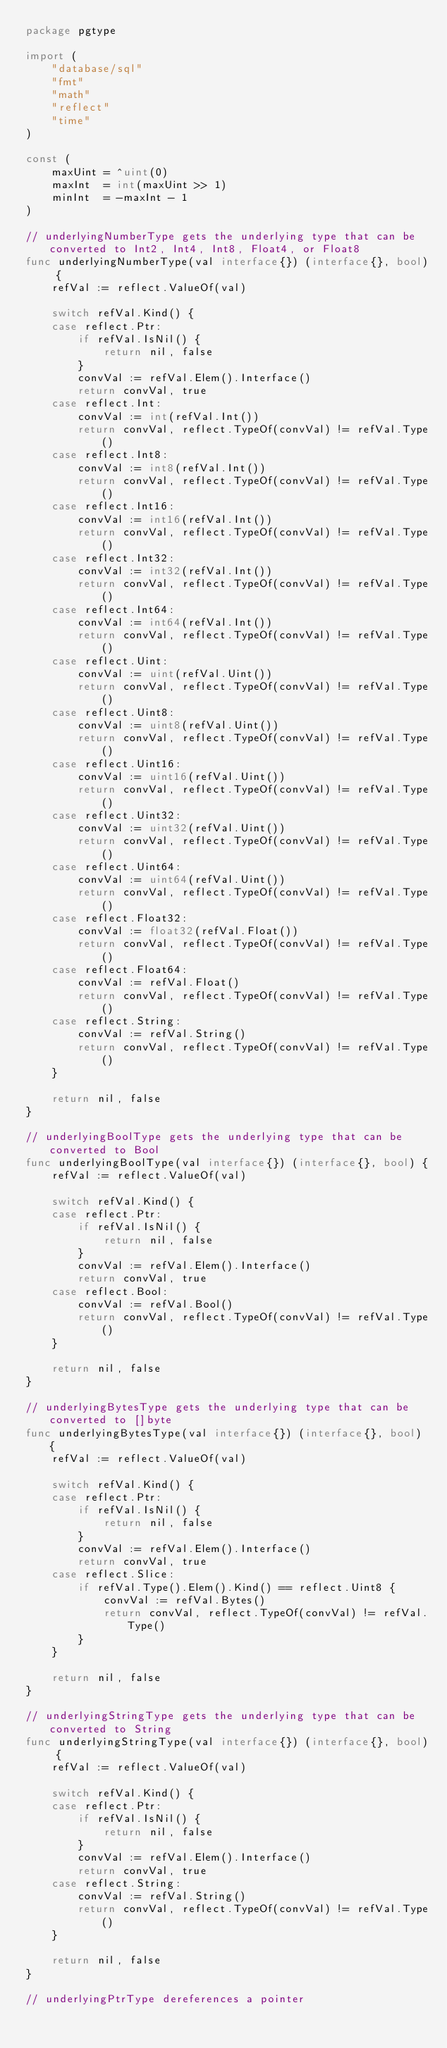Convert code to text. <code><loc_0><loc_0><loc_500><loc_500><_Go_>package pgtype

import (
	"database/sql"
	"fmt"
	"math"
	"reflect"
	"time"
)

const (
	maxUint = ^uint(0)
	maxInt  = int(maxUint >> 1)
	minInt  = -maxInt - 1
)

// underlyingNumberType gets the underlying type that can be converted to Int2, Int4, Int8, Float4, or Float8
func underlyingNumberType(val interface{}) (interface{}, bool) {
	refVal := reflect.ValueOf(val)

	switch refVal.Kind() {
	case reflect.Ptr:
		if refVal.IsNil() {
			return nil, false
		}
		convVal := refVal.Elem().Interface()
		return convVal, true
	case reflect.Int:
		convVal := int(refVal.Int())
		return convVal, reflect.TypeOf(convVal) != refVal.Type()
	case reflect.Int8:
		convVal := int8(refVal.Int())
		return convVal, reflect.TypeOf(convVal) != refVal.Type()
	case reflect.Int16:
		convVal := int16(refVal.Int())
		return convVal, reflect.TypeOf(convVal) != refVal.Type()
	case reflect.Int32:
		convVal := int32(refVal.Int())
		return convVal, reflect.TypeOf(convVal) != refVal.Type()
	case reflect.Int64:
		convVal := int64(refVal.Int())
		return convVal, reflect.TypeOf(convVal) != refVal.Type()
	case reflect.Uint:
		convVal := uint(refVal.Uint())
		return convVal, reflect.TypeOf(convVal) != refVal.Type()
	case reflect.Uint8:
		convVal := uint8(refVal.Uint())
		return convVal, reflect.TypeOf(convVal) != refVal.Type()
	case reflect.Uint16:
		convVal := uint16(refVal.Uint())
		return convVal, reflect.TypeOf(convVal) != refVal.Type()
	case reflect.Uint32:
		convVal := uint32(refVal.Uint())
		return convVal, reflect.TypeOf(convVal) != refVal.Type()
	case reflect.Uint64:
		convVal := uint64(refVal.Uint())
		return convVal, reflect.TypeOf(convVal) != refVal.Type()
	case reflect.Float32:
		convVal := float32(refVal.Float())
		return convVal, reflect.TypeOf(convVal) != refVal.Type()
	case reflect.Float64:
		convVal := refVal.Float()
		return convVal, reflect.TypeOf(convVal) != refVal.Type()
	case reflect.String:
		convVal := refVal.String()
		return convVal, reflect.TypeOf(convVal) != refVal.Type()
	}

	return nil, false
}

// underlyingBoolType gets the underlying type that can be converted to Bool
func underlyingBoolType(val interface{}) (interface{}, bool) {
	refVal := reflect.ValueOf(val)

	switch refVal.Kind() {
	case reflect.Ptr:
		if refVal.IsNil() {
			return nil, false
		}
		convVal := refVal.Elem().Interface()
		return convVal, true
	case reflect.Bool:
		convVal := refVal.Bool()
		return convVal, reflect.TypeOf(convVal) != refVal.Type()
	}

	return nil, false
}

// underlyingBytesType gets the underlying type that can be converted to []byte
func underlyingBytesType(val interface{}) (interface{}, bool) {
	refVal := reflect.ValueOf(val)

	switch refVal.Kind() {
	case reflect.Ptr:
		if refVal.IsNil() {
			return nil, false
		}
		convVal := refVal.Elem().Interface()
		return convVal, true
	case reflect.Slice:
		if refVal.Type().Elem().Kind() == reflect.Uint8 {
			convVal := refVal.Bytes()
			return convVal, reflect.TypeOf(convVal) != refVal.Type()
		}
	}

	return nil, false
}

// underlyingStringType gets the underlying type that can be converted to String
func underlyingStringType(val interface{}) (interface{}, bool) {
	refVal := reflect.ValueOf(val)

	switch refVal.Kind() {
	case reflect.Ptr:
		if refVal.IsNil() {
			return nil, false
		}
		convVal := refVal.Elem().Interface()
		return convVal, true
	case reflect.String:
		convVal := refVal.String()
		return convVal, reflect.TypeOf(convVal) != refVal.Type()
	}

	return nil, false
}

// underlyingPtrType dereferences a pointer</code> 